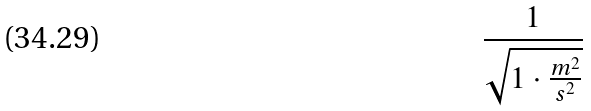<formula> <loc_0><loc_0><loc_500><loc_500>\frac { 1 } { \sqrt { 1 \cdot \frac { m ^ { 2 } } { s ^ { 2 } } } }</formula> 